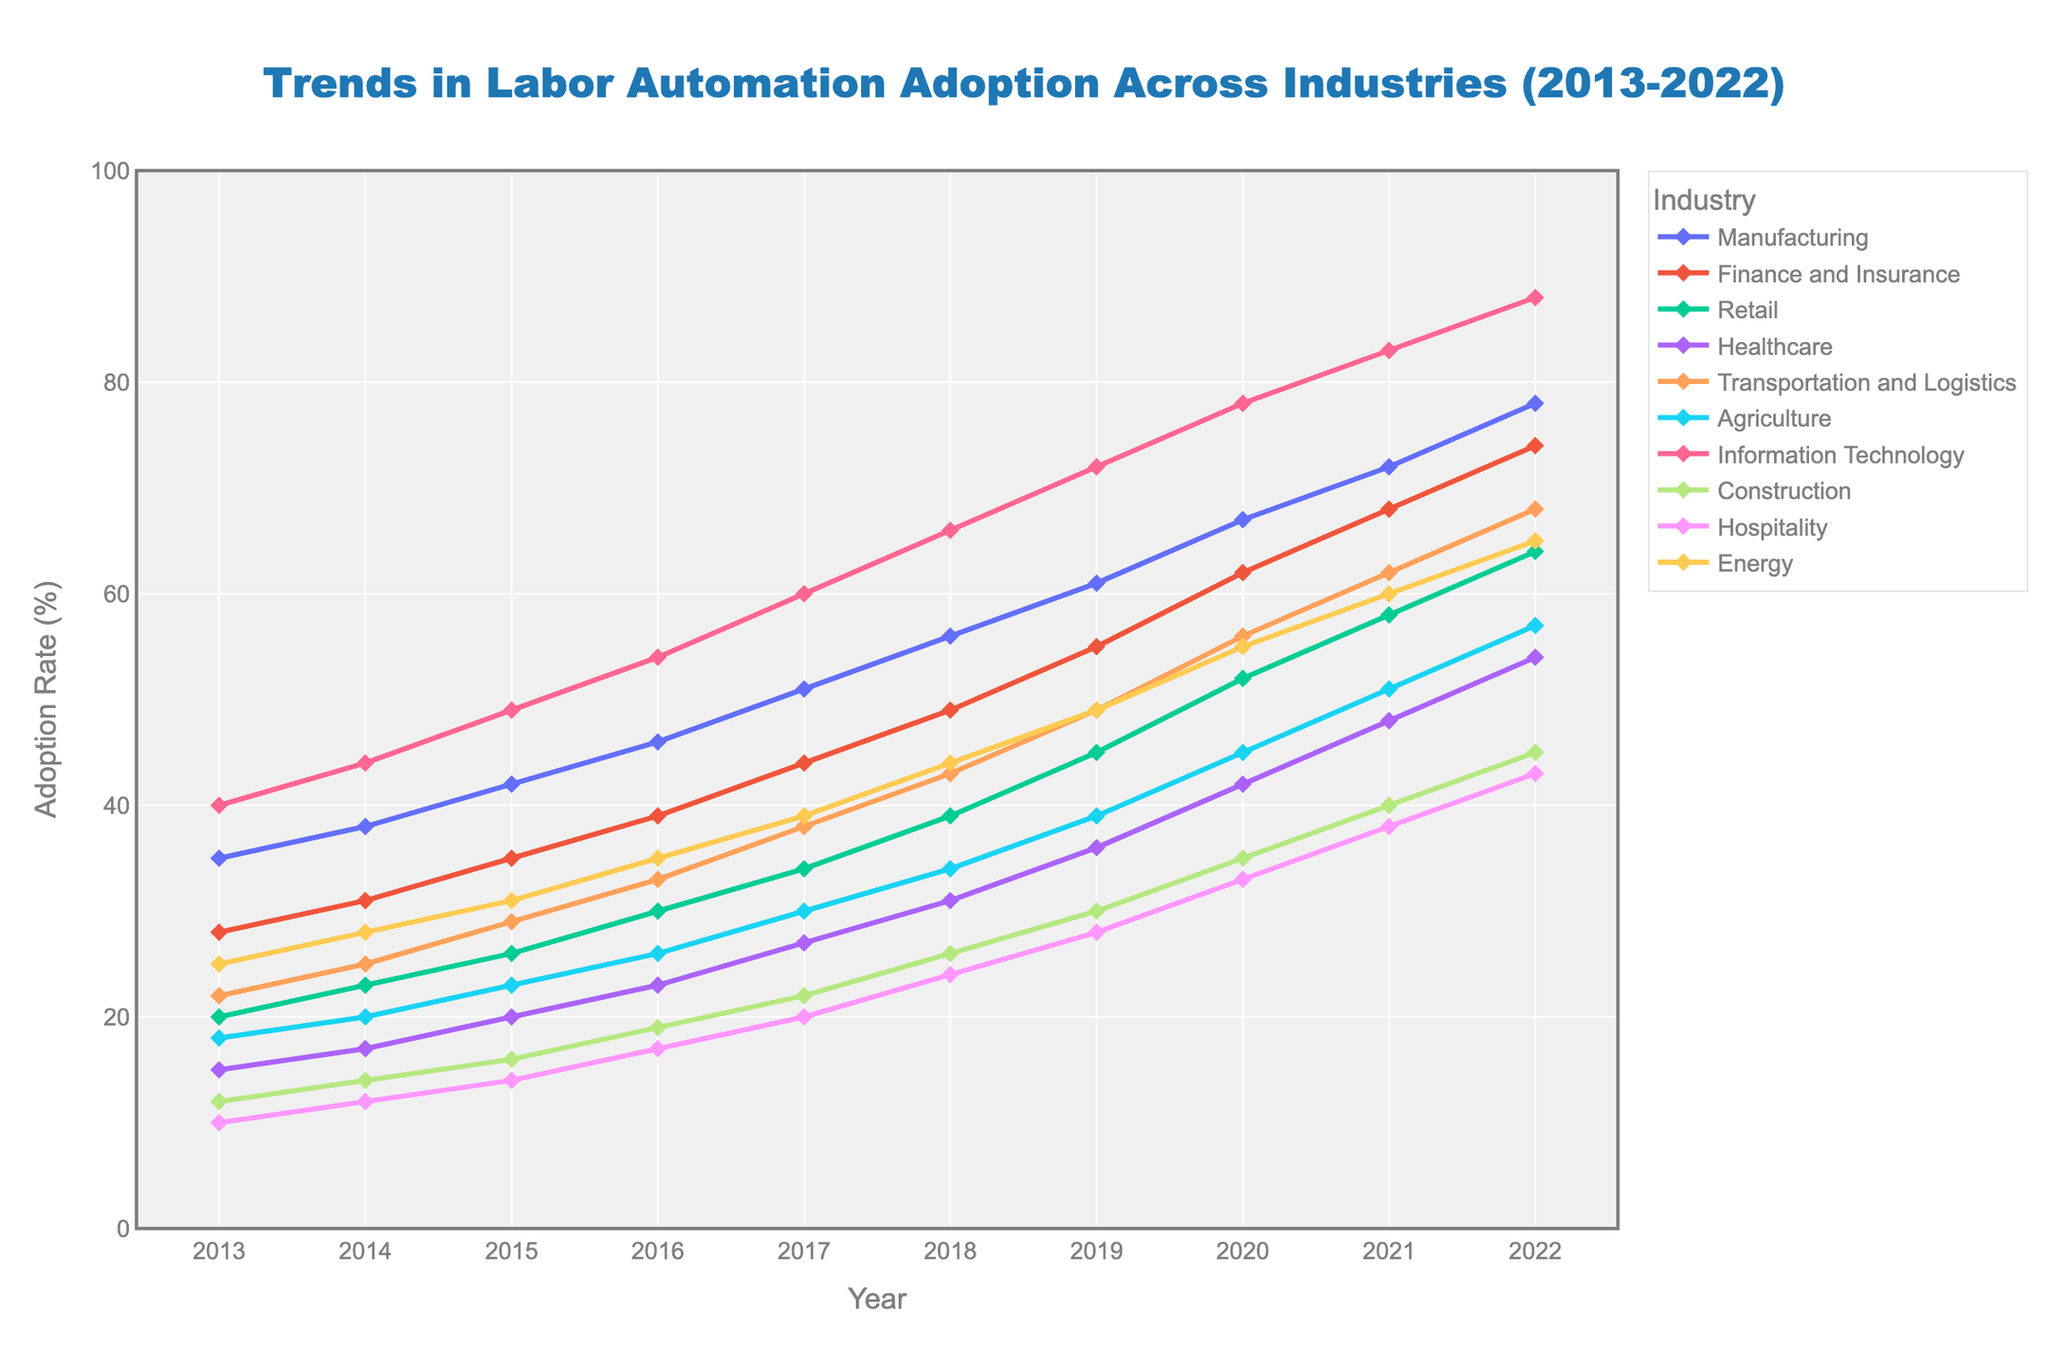Which industry had the highest adoption rate in 2022? To find the industry with the highest adoption rate in 2022, check the endpoints of all the lines on the graph for this year. The line for Information Technology reaches the highest point.
Answer: Information Technology What is the difference in adoption rate between Manufacturing and Healthcare in 2017? Locate the points for Manufacturing and Healthcare on the 2017 vertical line and note their adoption rates. Subtract Healthcare's rate from Manufacturing's rate. Manufacturing had 51%, and Healthcare had 27%, so the difference is 51 - 27 = 24.
Answer: 24% Which year saw the most significant increase in adoption rate for the Retail industry? To determine the year with the most significant increase, examine the slope of the line for Retail. The steepest line segment corresponds to the year 2017 to 2018.
Answer: 2017-2018 How does the adoption rate in Information Technology compare to Agriculture in 2016? Compare the points for Information Technology and Agriculture on the 2016 vertical line. Information Technology has a higher adoption rate (54%) than Agriculture (26%).
Answer: Information Technology > Agriculture What is the average adoption rate change for Construction from 2018 to 2022? Identify Construction’s adoption rates from 2018 to 2022 (26%, 30%, 35%, 40%, 45%). Calculate the yearly changes (30-26, 35-30, 40-35, 45-40), which are 4, 5, 5, 5. The average change is (4+5+5+5) / 4 = 4.75%.
Answer: 4.75% Which industry had the smallest increase in automation adoption from 2013 to 2022? Calculate the total increase for each industry by subtracting the 2013 rate from the 2022 rate. Compare these increments. Hospitality increased from 10% to 43%, a total increase of 33%, which is the smallest increase.
Answer: Hospitality What is the median adoption rate for all industries in 2020? List the adoption rates for all industries in 2020: [67, 62, 56, 42, 56, 45, 78, 35, 33, 55]. Sort these values: [33, 35, 42, 45, 55, 56, 56, 62, 67, 78]. The median is the average of the 5th and 6th values: (55+56)/2 = 55.5%.
Answer: 55.5% Which industry showed consistent yearly growth without any decrease in the adoption rate? Inspect the lines to see which industry shows a continuous upward trend without any breaks. All industries show a consistent increase, but Information Technology has a particularly steady incline with no dips or plateaus.
Answer: Information Technology In which year did the Transportation and Logistics industry surpass the Healthcare industry in automation adoption? Trace the adoption rates of both industries. They intersect around the year 2018, where Transportation and Logistics (43%) overtakes Healthcare (31%).
Answer: 2018 